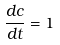<formula> <loc_0><loc_0><loc_500><loc_500>\frac { d c } { d t } = 1</formula> 